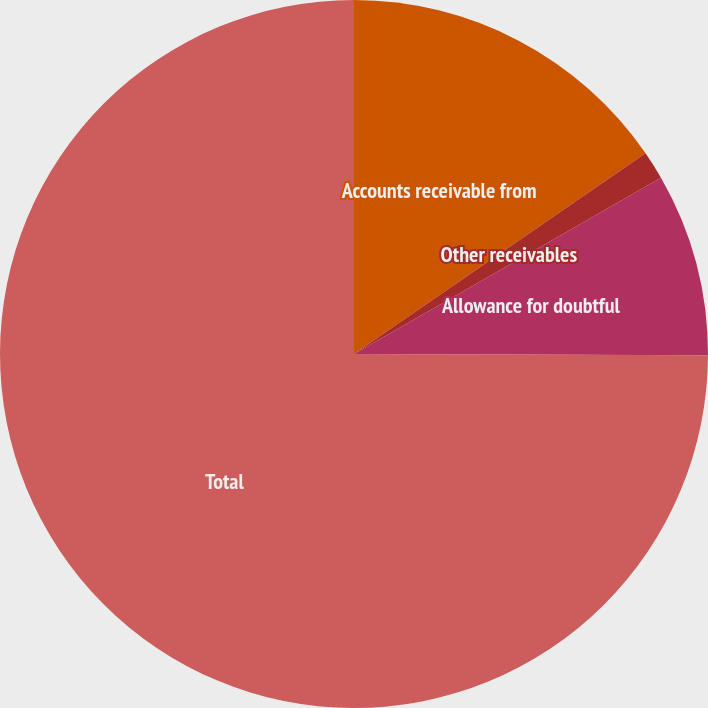Convert chart to OTSL. <chart><loc_0><loc_0><loc_500><loc_500><pie_chart><fcel>Accounts receivable from<fcel>Other receivables<fcel>Allowance for doubtful<fcel>Total<nl><fcel>15.4%<fcel>1.3%<fcel>8.35%<fcel>74.94%<nl></chart> 